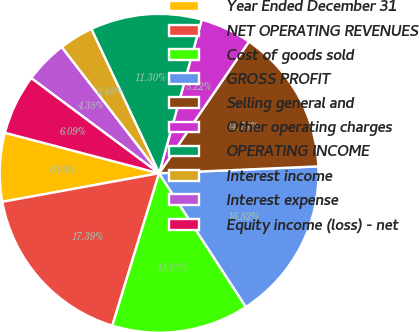<chart> <loc_0><loc_0><loc_500><loc_500><pie_chart><fcel>Year Ended December 31<fcel>NET OPERATING REVENUES<fcel>Cost of goods sold<fcel>GROSS PROFIT<fcel>Selling general and<fcel>Other operating charges<fcel>OPERATING INCOME<fcel>Interest income<fcel>Interest expense<fcel>Equity income (loss) - net<nl><fcel>6.96%<fcel>17.39%<fcel>13.91%<fcel>16.52%<fcel>14.78%<fcel>5.22%<fcel>11.3%<fcel>3.48%<fcel>4.35%<fcel>6.09%<nl></chart> 